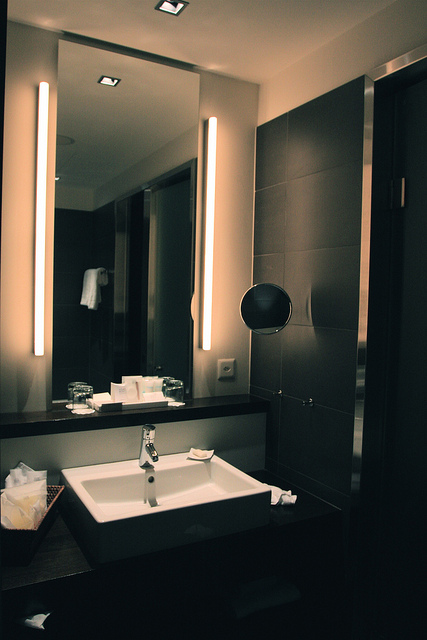Can you describe the mirror's location? Yes, there are two mirrors in the image. One is positioned on the left side, extending from the ceiling down to about the middle of the wall, bordered by two long vertical light fixtures. The other, smaller mirror is located on the right side, midway up the wall. 